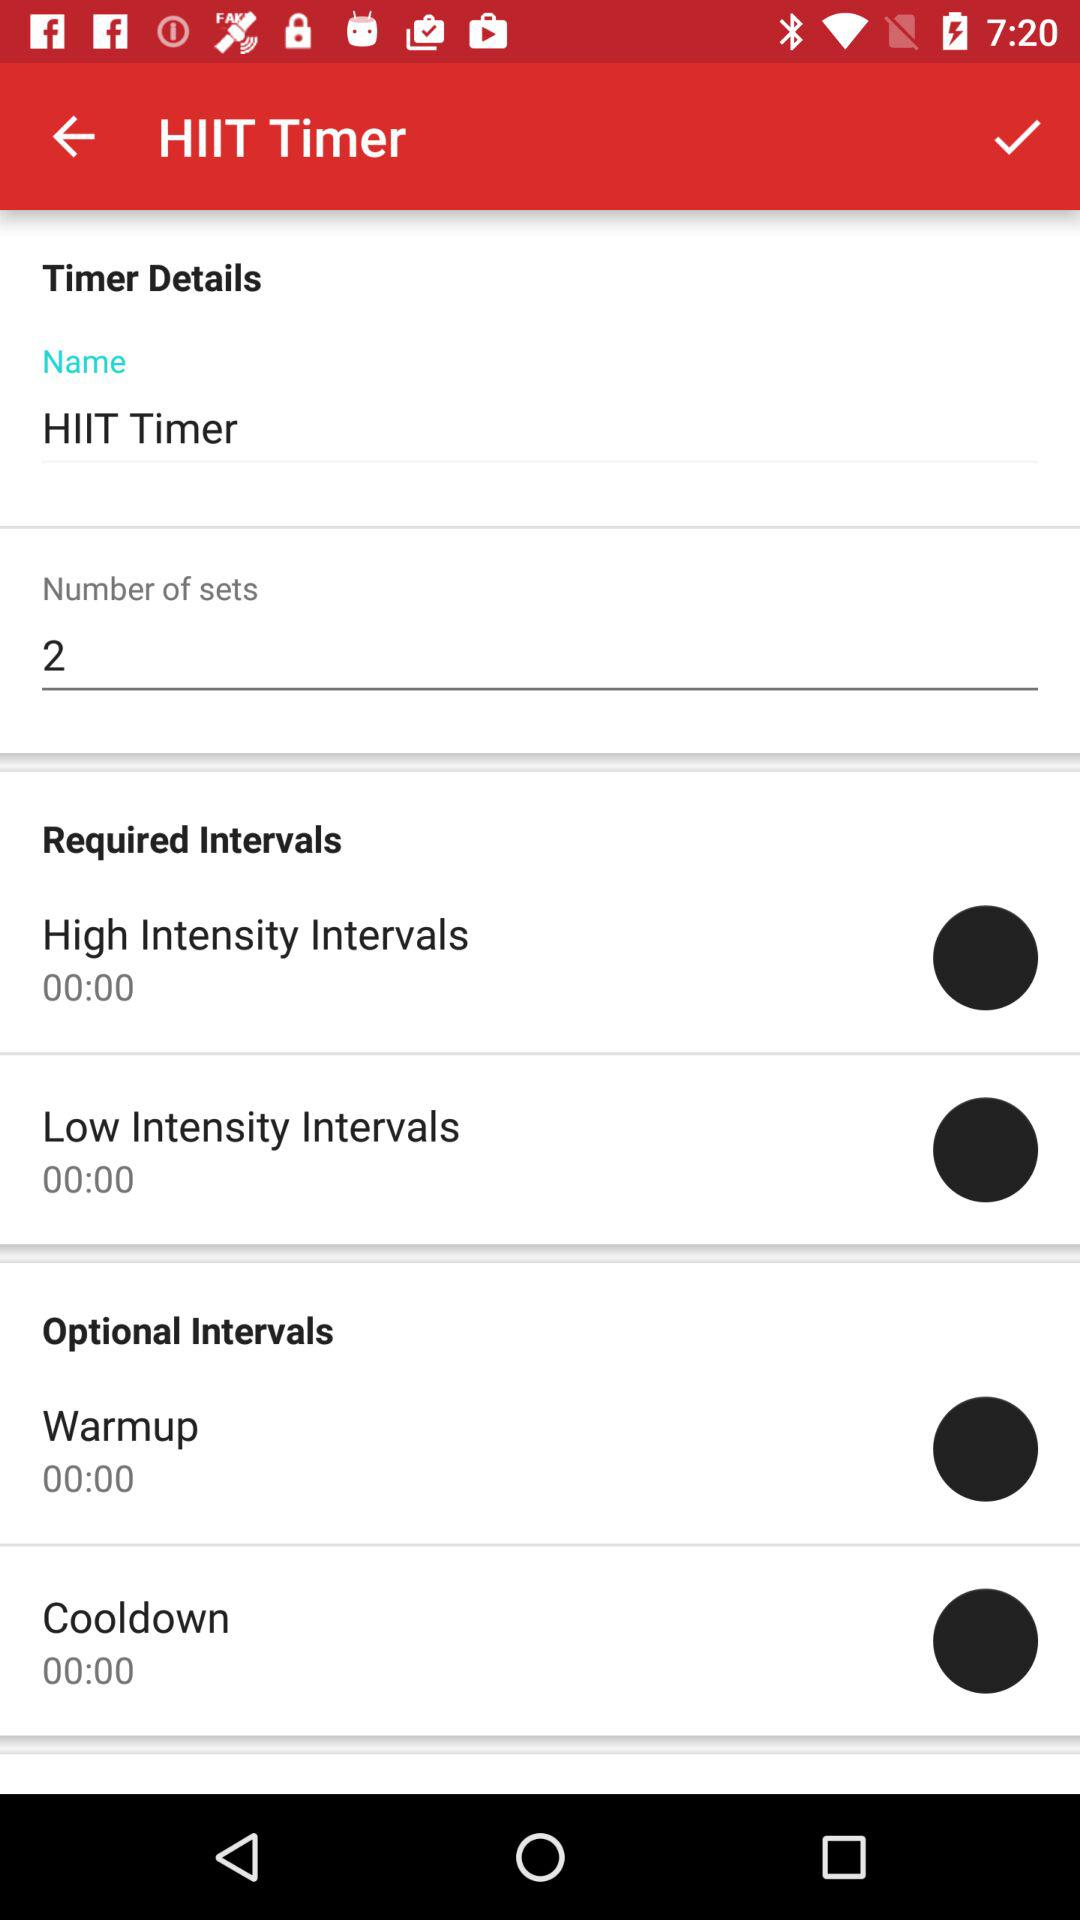How long is the warmup interval?
Answer the question using a single word or phrase. 00:00 